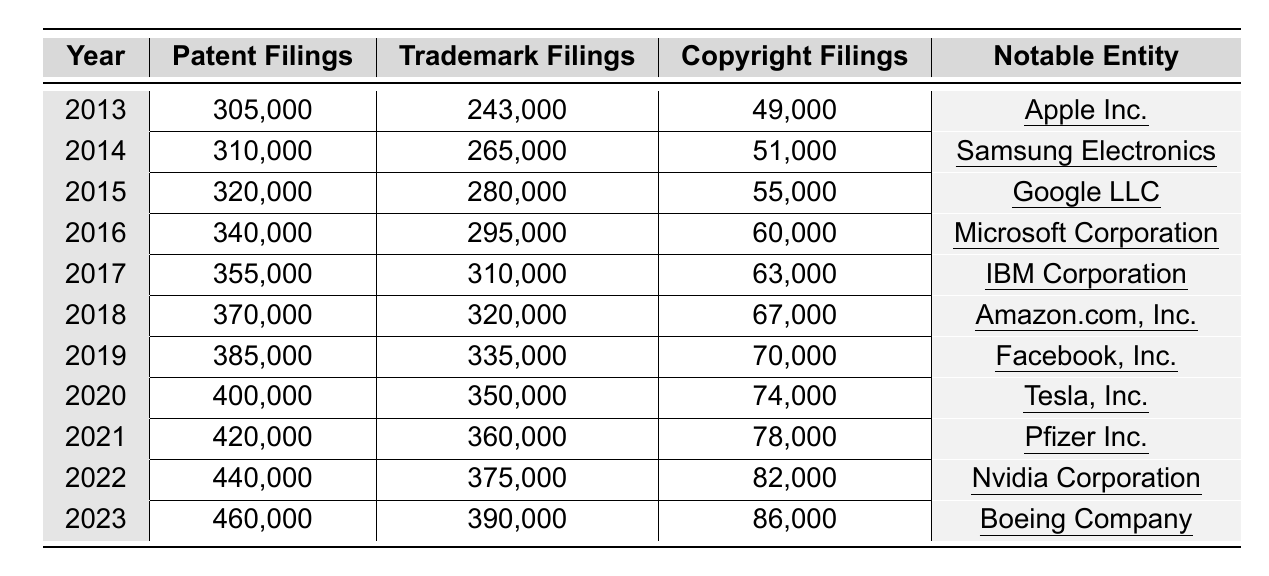What was the notable entity in 2015? The table indicates that the notable entity for the year 2015 is Google LLC.
Answer: Google LLC How many copyright filings were there in 2021? According to the table, there were 78,000 copyright filings in 2021.
Answer: 78,000 What was the increase in patent filings from 2013 to 2023? The patent filings in 2013 were 305,000 and in 2023 they were 460,000. The increase is 460,000 - 305,000 = 155,000.
Answer: 155,000 In which year did IBM Corporation have the highest trademark filings? From the table, IBM Corporation had the highest trademark filings in 2017, with 310,000 filings.
Answer: 2017 What is the average number of trademark filings from 2013 to 2023? The total number of trademark filings from 2013 (243,000) to 2023 (390,000) is 243,000 + 265,000 + 280,000 + 295,000 + 310,000 + 320,000 + 335,000 + 350,000 + 360,000 + 375,000 + 390,000 = 3,105,000. Dividing this by 11 (the number of years) gives an average of 3,105,000 / 11 = 282,273.
Answer: 282,273 Did trademark filings ever exceed patent filings during this period? A comparison of the numbers reveals that for every year from 2013 to 2023, trademark filings never exceeded patent filings.
Answer: No What were the trademark filings in the year with the highest growth in patent filings? The year with the highest growth in patent filings was from 2022 to 2023, where the increase was 460,000 - 440,000 = 20,000. In 2023, trademark filings were 390,000.
Answer: 390,000 Which notable entity had the highest number of copyright filings, and in what year? The year 2023 saw the highest copyright filings with the notable entity being Boeing Company, totaling 86,000 filings.
Answer: Boeing Company, 2023 What is the total number of copyright filings from 2013 to 2023? To find the total copyright filings from 2013 to 2023, we sum up the filings: 49,000 + 51,000 + 55,000 + 60,000 + 63,000 + 67,000 + 70,000 + 74,000 + 78,000 + 82,000 + 86,000 =  86,000.
Answer: 86,000 Which year showed the highest overall intellectual property filings when combining all categories? To determine this, we sum the filings for 2023: 460,000 (patents) + 390,000 (trademarks) + 86,000 (copyrights) = 936,000, which was the highest across the years.
Answer: 2023 